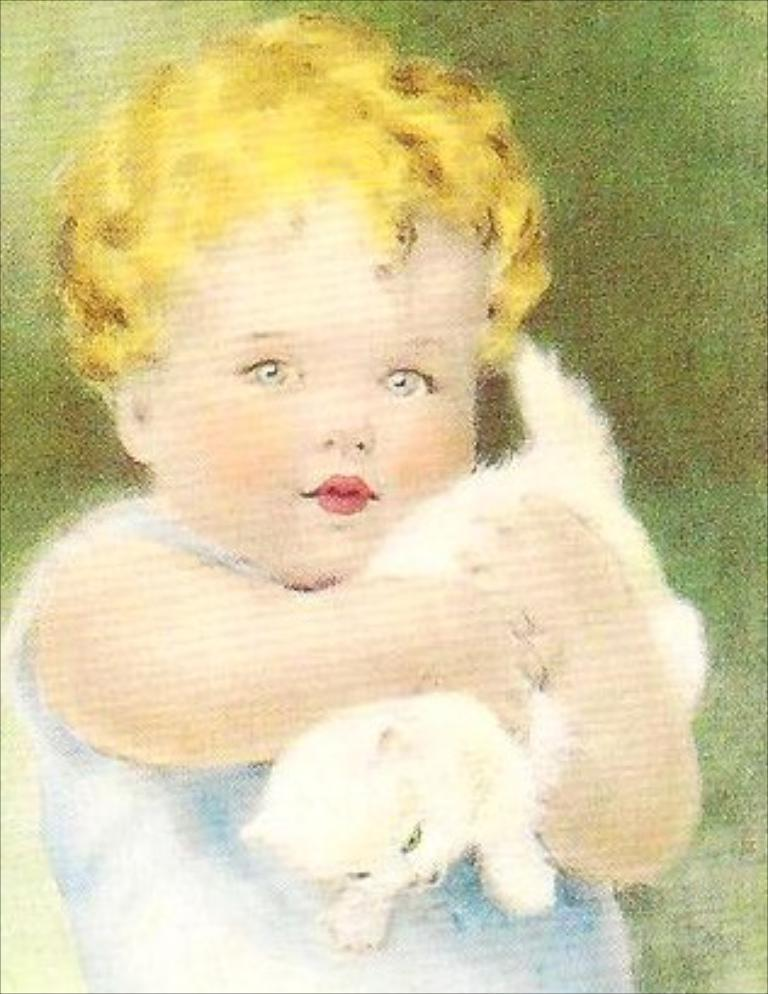What is the main subject of the image? There is a painting in the image. What is the painting depicting? The painting depicts a girl. What is the girl holding in the painting? The girl is holding a cat in her hand. What type of mask is the girl wearing in the painting? There is no mask present in the painting; the girl is holding a cat in her hand. What is the girl protesting in the painting? There is no protest depicted in the painting; it features a girl holding a cat. 